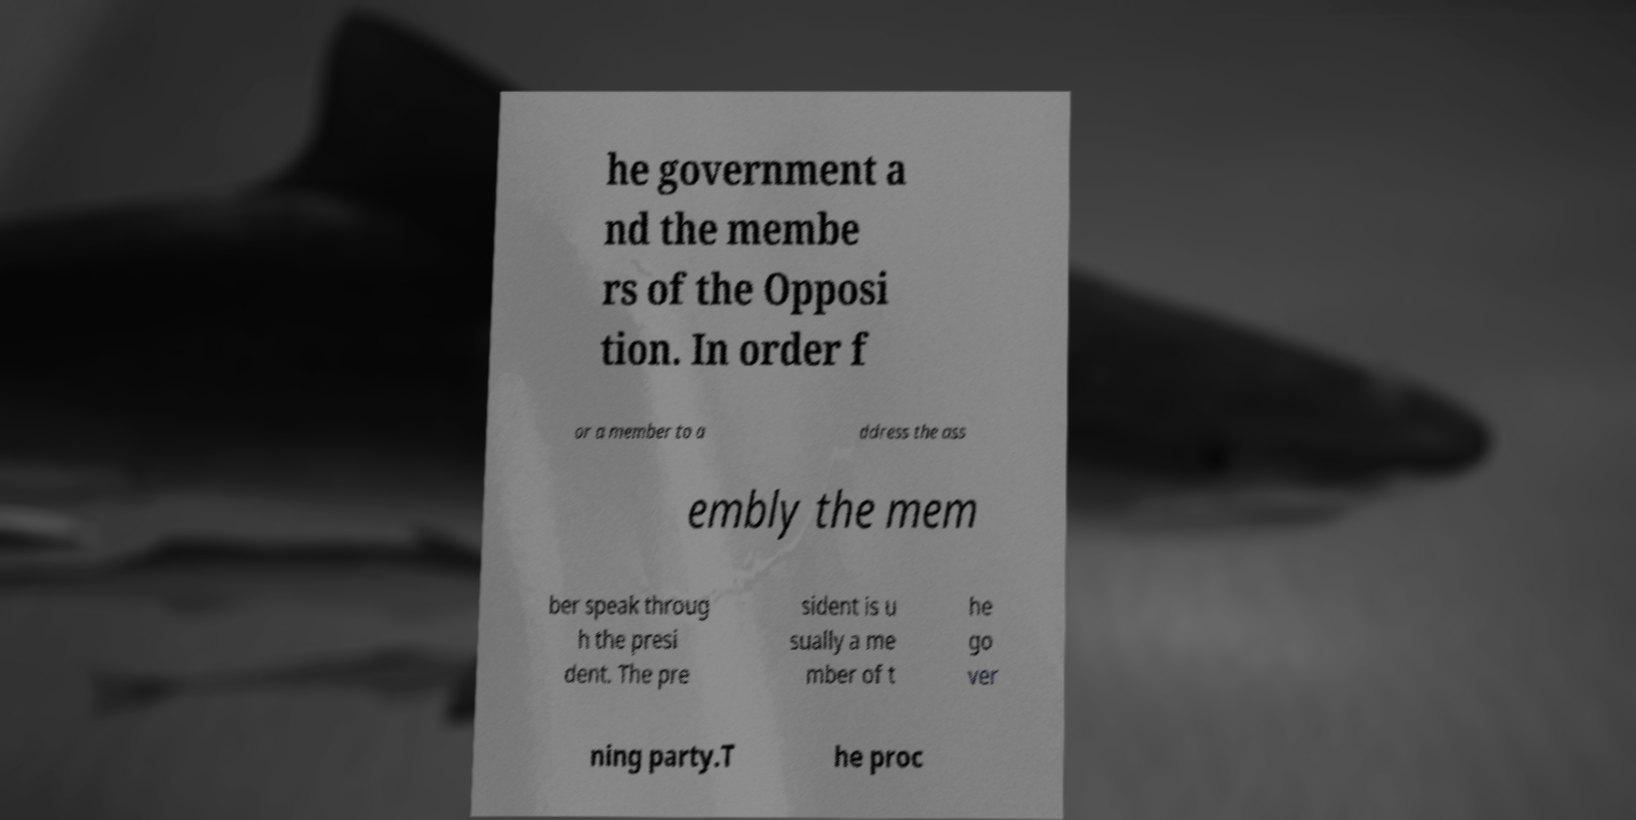Please read and relay the text visible in this image. What does it say? he government a nd the membe rs of the Opposi tion. In order f or a member to a ddress the ass embly the mem ber speak throug h the presi dent. The pre sident is u sually a me mber of t he go ver ning party.T he proc 